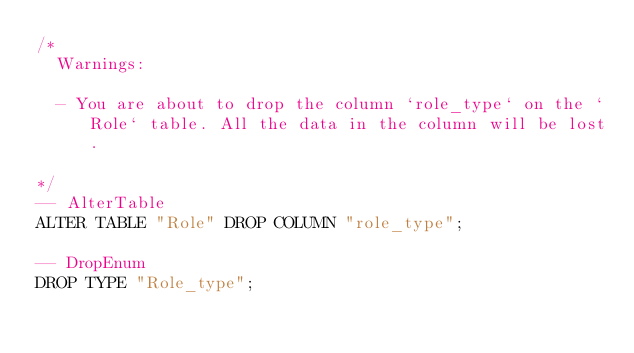Convert code to text. <code><loc_0><loc_0><loc_500><loc_500><_SQL_>/*
  Warnings:

  - You are about to drop the column `role_type` on the `Role` table. All the data in the column will be lost.

*/
-- AlterTable
ALTER TABLE "Role" DROP COLUMN "role_type";

-- DropEnum
DROP TYPE "Role_type";
</code> 